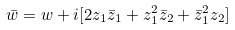Convert formula to latex. <formula><loc_0><loc_0><loc_500><loc_500>\bar { w } = w + i [ 2 z _ { 1 } \bar { z } _ { 1 } + z _ { 1 } ^ { 2 } \bar { z } _ { 2 } + \bar { z } _ { 1 } ^ { 2 } z _ { 2 } ]</formula> 